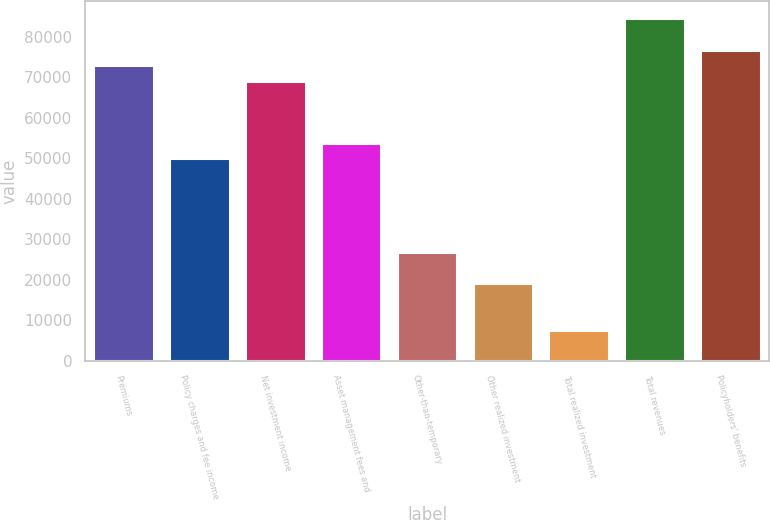Convert chart. <chart><loc_0><loc_0><loc_500><loc_500><bar_chart><fcel>Premiums<fcel>Policy charges and fee income<fcel>Net investment income<fcel>Asset management fees and<fcel>Other-than-temporary<fcel>Other realized investment<fcel>Total realized investment<fcel>Total revenues<fcel>Policyholders' benefits<nl><fcel>72977.6<fcel>49935.2<fcel>69137.2<fcel>53775.6<fcel>26892.8<fcel>19212<fcel>7690.8<fcel>84498.8<fcel>76818<nl></chart> 